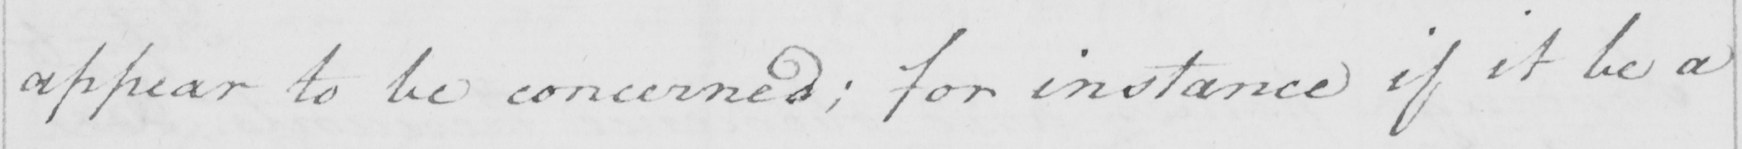Can you read and transcribe this handwriting? appear to be concerned ; for instance if it be a 